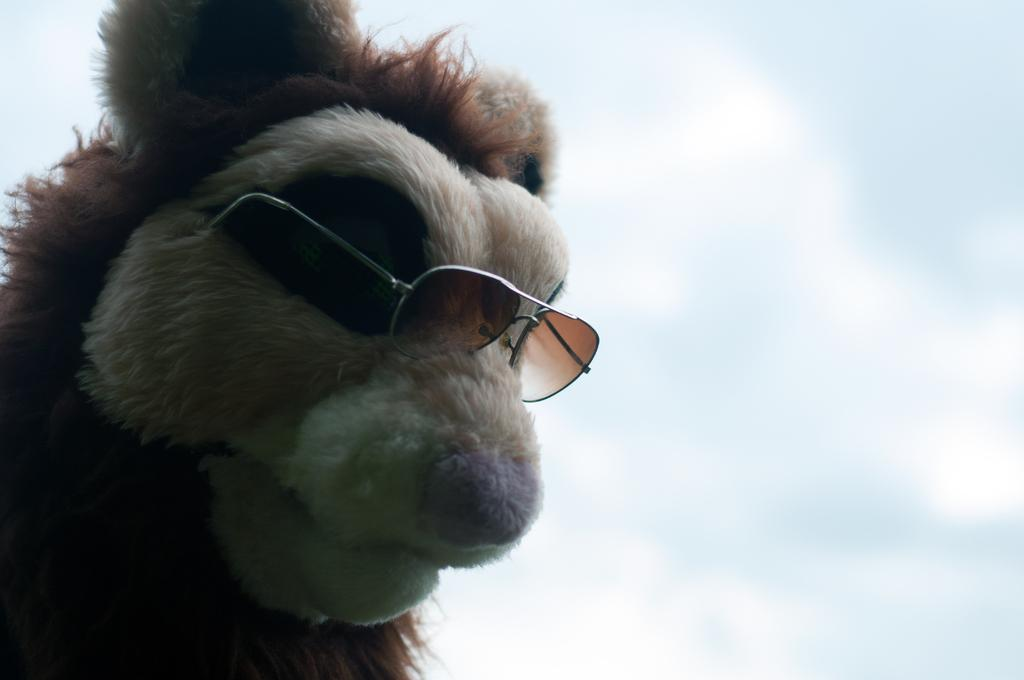What is the main subject in the foreground of the picture? There is a toy in the foreground of the picture. What feature does the toy have? The toy is wearing spectacles. What can be seen in the background of the picture? The sky is visible in the background of the picture. What type of underwear is the toy wearing in the picture? The toy is not wearing any underwear in the picture. Are there any jeans visible in the picture? There are no jeans present in the picture. 